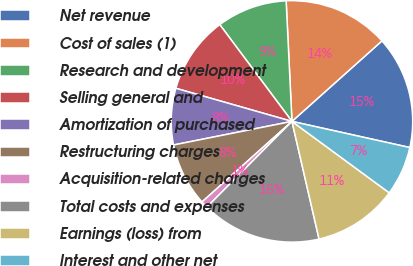<chart> <loc_0><loc_0><loc_500><loc_500><pie_chart><fcel>Net revenue<fcel>Cost of sales (1)<fcel>Research and development<fcel>Selling general and<fcel>Amortization of purchased<fcel>Restructuring charges<fcel>Acquisition-related charges<fcel>Total costs and expenses<fcel>Earnings (loss) from<fcel>Interest and other net<nl><fcel>15.09%<fcel>14.15%<fcel>9.43%<fcel>10.38%<fcel>7.55%<fcel>8.49%<fcel>0.94%<fcel>16.04%<fcel>11.32%<fcel>6.6%<nl></chart> 